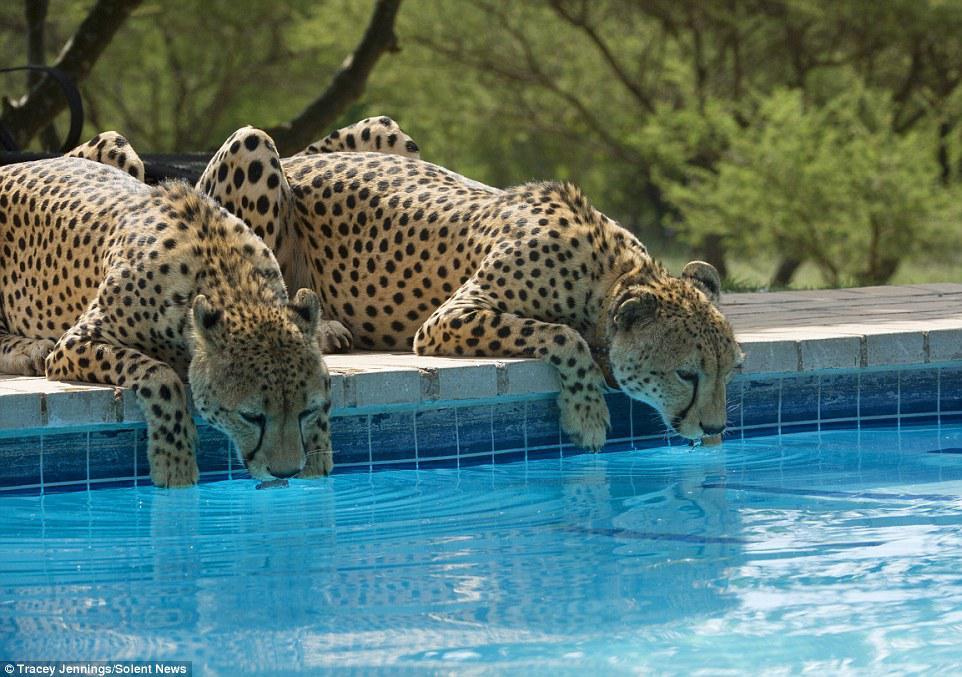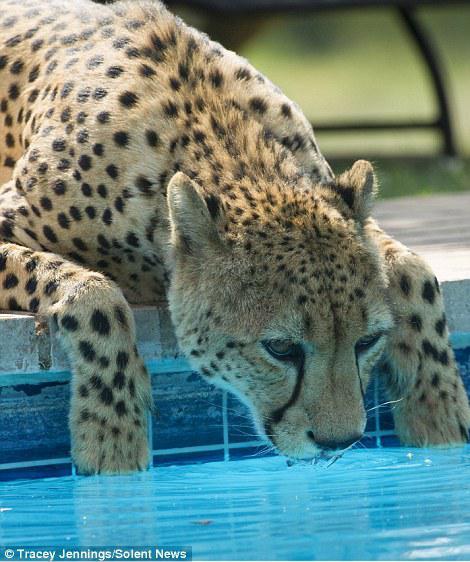The first image is the image on the left, the second image is the image on the right. Evaluate the accuracy of this statement regarding the images: "There is a leopard looking into a swimming pool in each image.". Is it true? Answer yes or no. Yes. The first image is the image on the left, the second image is the image on the right. Analyze the images presented: Is the assertion "Each image shows at least one spotted wild cat leaning to drink out of a manmade swimming pool." valid? Answer yes or no. Yes. 